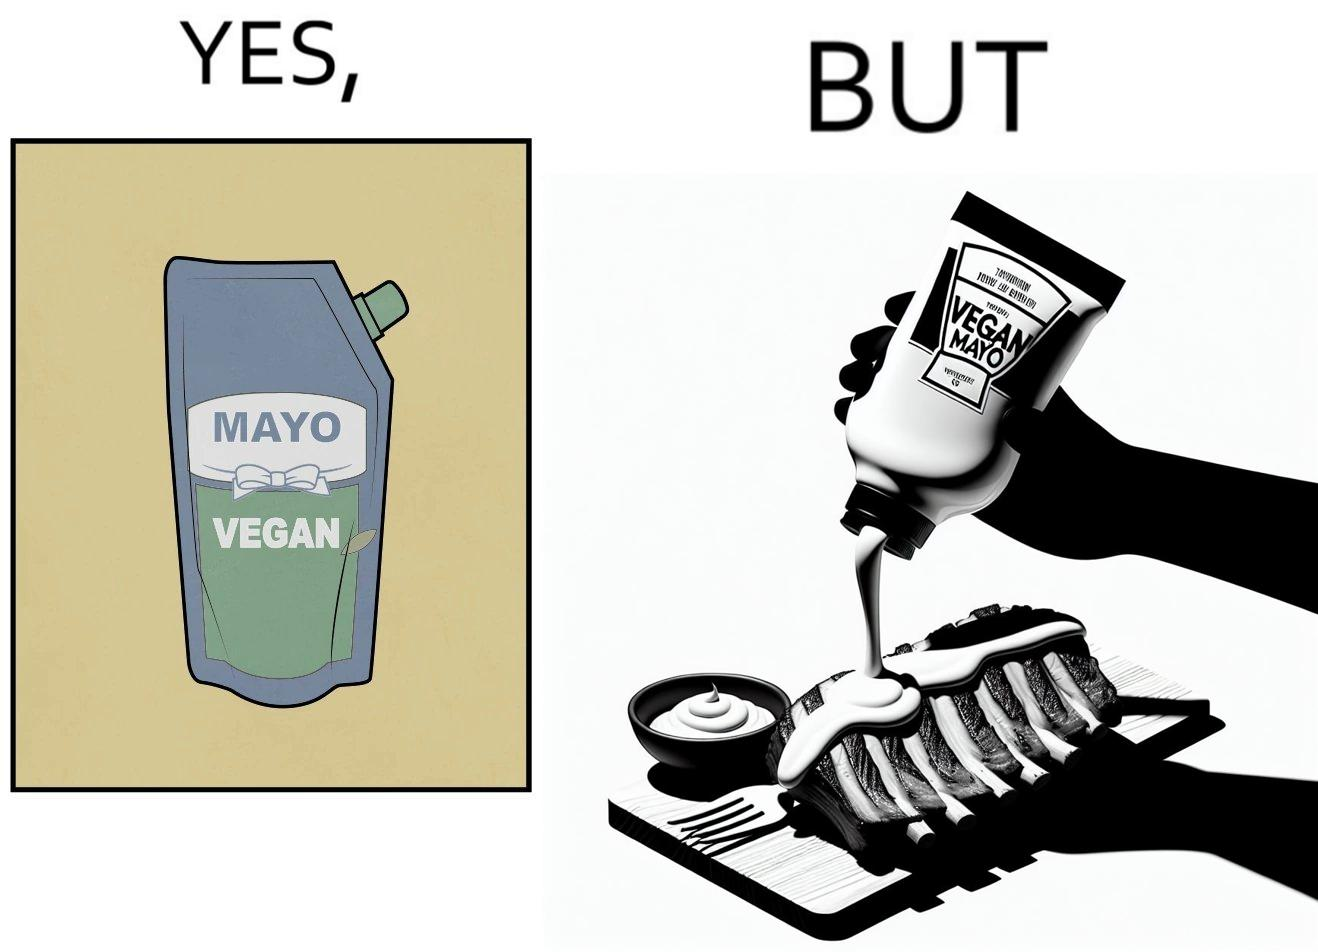Describe what you see in the left and right parts of this image. In the left part of the image: a vegan mayo sauce packet In the right part of the image: pouring vegan mayo sauce from a packet on a rib steak 